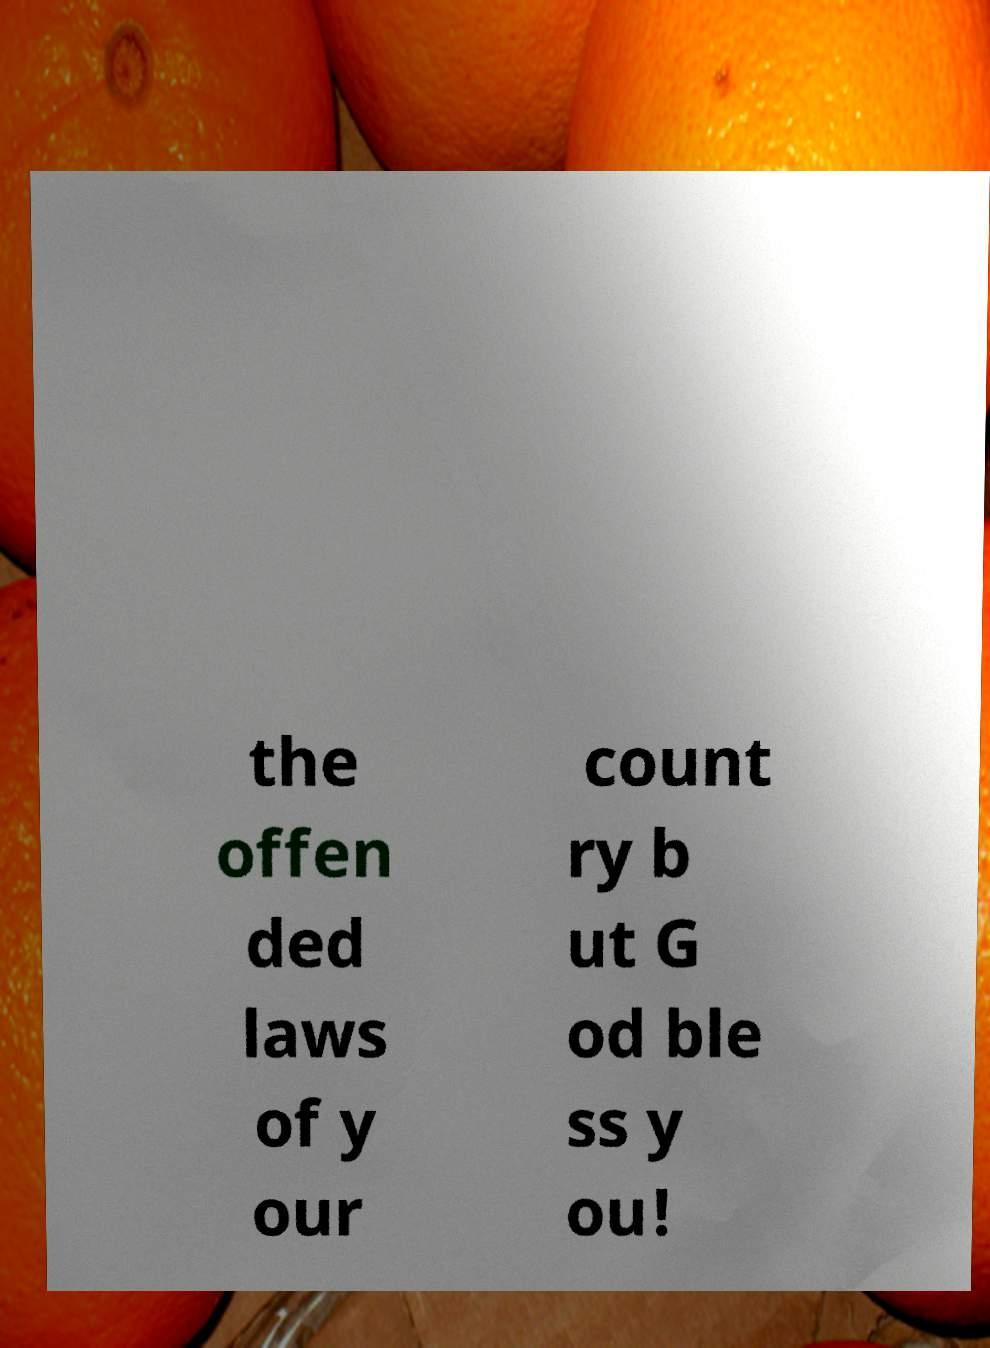For documentation purposes, I need the text within this image transcribed. Could you provide that? the offen ded laws of y our count ry b ut G od ble ss y ou! 